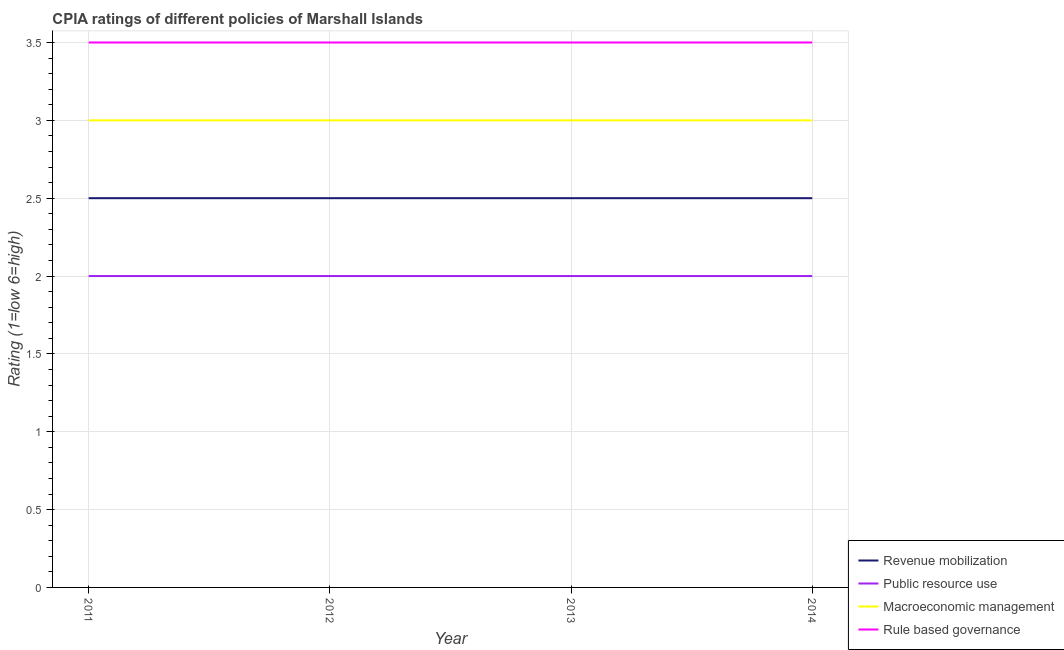How many different coloured lines are there?
Keep it short and to the point. 4. What is the total cpia rating of public resource use in the graph?
Your answer should be compact. 8. What is the difference between the cpia rating of revenue mobilization in 2011 and that in 2012?
Make the answer very short. 0. What is the average cpia rating of public resource use per year?
Your response must be concise. 2. Is it the case that in every year, the sum of the cpia rating of rule based governance and cpia rating of revenue mobilization is greater than the sum of cpia rating of public resource use and cpia rating of macroeconomic management?
Provide a short and direct response. No. Is it the case that in every year, the sum of the cpia rating of revenue mobilization and cpia rating of public resource use is greater than the cpia rating of macroeconomic management?
Ensure brevity in your answer.  Yes. Does the cpia rating of revenue mobilization monotonically increase over the years?
Make the answer very short. No. Is the cpia rating of macroeconomic management strictly greater than the cpia rating of rule based governance over the years?
Keep it short and to the point. No. How many lines are there?
Provide a succinct answer. 4. How many years are there in the graph?
Offer a very short reply. 4. What is the difference between two consecutive major ticks on the Y-axis?
Your answer should be very brief. 0.5. Are the values on the major ticks of Y-axis written in scientific E-notation?
Your answer should be very brief. No. Where does the legend appear in the graph?
Make the answer very short. Bottom right. What is the title of the graph?
Ensure brevity in your answer.  CPIA ratings of different policies of Marshall Islands. Does "Rule based governance" appear as one of the legend labels in the graph?
Offer a very short reply. Yes. What is the Rating (1=low 6=high) of Revenue mobilization in 2011?
Offer a very short reply. 2.5. What is the Rating (1=low 6=high) of Public resource use in 2011?
Offer a very short reply. 2. What is the Rating (1=low 6=high) of Macroeconomic management in 2011?
Provide a succinct answer. 3. What is the Rating (1=low 6=high) of Revenue mobilization in 2013?
Give a very brief answer. 2.5. What is the Rating (1=low 6=high) in Macroeconomic management in 2013?
Keep it short and to the point. 3. What is the Rating (1=low 6=high) in Rule based governance in 2013?
Your response must be concise. 3.5. What is the Rating (1=low 6=high) of Revenue mobilization in 2014?
Provide a succinct answer. 2.5. What is the Rating (1=low 6=high) of Rule based governance in 2014?
Your answer should be very brief. 3.5. Across all years, what is the maximum Rating (1=low 6=high) in Revenue mobilization?
Give a very brief answer. 2.5. Across all years, what is the maximum Rating (1=low 6=high) of Public resource use?
Offer a terse response. 2. Across all years, what is the minimum Rating (1=low 6=high) of Public resource use?
Keep it short and to the point. 2. Across all years, what is the minimum Rating (1=low 6=high) in Macroeconomic management?
Provide a succinct answer. 3. Across all years, what is the minimum Rating (1=low 6=high) in Rule based governance?
Give a very brief answer. 3.5. What is the total Rating (1=low 6=high) of Revenue mobilization in the graph?
Provide a short and direct response. 10. What is the difference between the Rating (1=low 6=high) in Revenue mobilization in 2011 and that in 2012?
Provide a short and direct response. 0. What is the difference between the Rating (1=low 6=high) of Public resource use in 2011 and that in 2012?
Give a very brief answer. 0. What is the difference between the Rating (1=low 6=high) in Rule based governance in 2011 and that in 2012?
Offer a terse response. 0. What is the difference between the Rating (1=low 6=high) of Rule based governance in 2011 and that in 2013?
Offer a terse response. 0. What is the difference between the Rating (1=low 6=high) in Macroeconomic management in 2011 and that in 2014?
Ensure brevity in your answer.  0. What is the difference between the Rating (1=low 6=high) in Public resource use in 2012 and that in 2013?
Offer a very short reply. 0. What is the difference between the Rating (1=low 6=high) in Macroeconomic management in 2012 and that in 2013?
Provide a succinct answer. 0. What is the difference between the Rating (1=low 6=high) in Revenue mobilization in 2012 and that in 2014?
Your answer should be compact. 0. What is the difference between the Rating (1=low 6=high) in Public resource use in 2012 and that in 2014?
Offer a very short reply. 0. What is the difference between the Rating (1=low 6=high) of Macroeconomic management in 2012 and that in 2014?
Your response must be concise. 0. What is the difference between the Rating (1=low 6=high) in Public resource use in 2013 and that in 2014?
Your answer should be very brief. 0. What is the difference between the Rating (1=low 6=high) in Rule based governance in 2013 and that in 2014?
Provide a succinct answer. 0. What is the difference between the Rating (1=low 6=high) in Revenue mobilization in 2011 and the Rating (1=low 6=high) in Public resource use in 2012?
Offer a terse response. 0.5. What is the difference between the Rating (1=low 6=high) of Revenue mobilization in 2011 and the Rating (1=low 6=high) of Macroeconomic management in 2012?
Your response must be concise. -0.5. What is the difference between the Rating (1=low 6=high) of Revenue mobilization in 2011 and the Rating (1=low 6=high) of Rule based governance in 2012?
Provide a succinct answer. -1. What is the difference between the Rating (1=low 6=high) of Public resource use in 2011 and the Rating (1=low 6=high) of Rule based governance in 2012?
Give a very brief answer. -1.5. What is the difference between the Rating (1=low 6=high) of Revenue mobilization in 2011 and the Rating (1=low 6=high) of Rule based governance in 2013?
Keep it short and to the point. -1. What is the difference between the Rating (1=low 6=high) in Public resource use in 2011 and the Rating (1=low 6=high) in Macroeconomic management in 2013?
Your response must be concise. -1. What is the difference between the Rating (1=low 6=high) of Revenue mobilization in 2011 and the Rating (1=low 6=high) of Public resource use in 2014?
Offer a very short reply. 0.5. What is the difference between the Rating (1=low 6=high) of Public resource use in 2011 and the Rating (1=low 6=high) of Macroeconomic management in 2014?
Offer a terse response. -1. What is the difference between the Rating (1=low 6=high) of Public resource use in 2011 and the Rating (1=low 6=high) of Rule based governance in 2014?
Your answer should be very brief. -1.5. What is the difference between the Rating (1=low 6=high) of Macroeconomic management in 2011 and the Rating (1=low 6=high) of Rule based governance in 2014?
Provide a short and direct response. -0.5. What is the difference between the Rating (1=low 6=high) of Revenue mobilization in 2012 and the Rating (1=low 6=high) of Rule based governance in 2013?
Your answer should be compact. -1. What is the difference between the Rating (1=low 6=high) in Public resource use in 2012 and the Rating (1=low 6=high) in Rule based governance in 2013?
Provide a succinct answer. -1.5. What is the difference between the Rating (1=low 6=high) in Revenue mobilization in 2012 and the Rating (1=low 6=high) in Rule based governance in 2014?
Keep it short and to the point. -1. What is the difference between the Rating (1=low 6=high) of Public resource use in 2012 and the Rating (1=low 6=high) of Macroeconomic management in 2014?
Your response must be concise. -1. What is the difference between the Rating (1=low 6=high) in Public resource use in 2012 and the Rating (1=low 6=high) in Rule based governance in 2014?
Provide a succinct answer. -1.5. What is the difference between the Rating (1=low 6=high) in Revenue mobilization in 2013 and the Rating (1=low 6=high) in Public resource use in 2014?
Make the answer very short. 0.5. What is the difference between the Rating (1=low 6=high) in Revenue mobilization in 2013 and the Rating (1=low 6=high) in Macroeconomic management in 2014?
Your answer should be compact. -0.5. What is the difference between the Rating (1=low 6=high) in Macroeconomic management in 2013 and the Rating (1=low 6=high) in Rule based governance in 2014?
Your response must be concise. -0.5. What is the average Rating (1=low 6=high) in Revenue mobilization per year?
Ensure brevity in your answer.  2.5. What is the average Rating (1=low 6=high) of Public resource use per year?
Give a very brief answer. 2. What is the average Rating (1=low 6=high) of Macroeconomic management per year?
Offer a terse response. 3. What is the average Rating (1=low 6=high) in Rule based governance per year?
Provide a short and direct response. 3.5. In the year 2011, what is the difference between the Rating (1=low 6=high) of Revenue mobilization and Rating (1=low 6=high) of Public resource use?
Your answer should be compact. 0.5. In the year 2011, what is the difference between the Rating (1=low 6=high) in Public resource use and Rating (1=low 6=high) in Rule based governance?
Your answer should be compact. -1.5. In the year 2012, what is the difference between the Rating (1=low 6=high) of Revenue mobilization and Rating (1=low 6=high) of Public resource use?
Your answer should be compact. 0.5. In the year 2012, what is the difference between the Rating (1=low 6=high) in Public resource use and Rating (1=low 6=high) in Rule based governance?
Offer a terse response. -1.5. In the year 2012, what is the difference between the Rating (1=low 6=high) of Macroeconomic management and Rating (1=low 6=high) of Rule based governance?
Offer a terse response. -0.5. In the year 2013, what is the difference between the Rating (1=low 6=high) in Revenue mobilization and Rating (1=low 6=high) in Macroeconomic management?
Your response must be concise. -0.5. In the year 2014, what is the difference between the Rating (1=low 6=high) in Revenue mobilization and Rating (1=low 6=high) in Rule based governance?
Make the answer very short. -1. In the year 2014, what is the difference between the Rating (1=low 6=high) of Public resource use and Rating (1=low 6=high) of Macroeconomic management?
Your response must be concise. -1. In the year 2014, what is the difference between the Rating (1=low 6=high) of Macroeconomic management and Rating (1=low 6=high) of Rule based governance?
Give a very brief answer. -0.5. What is the ratio of the Rating (1=low 6=high) in Public resource use in 2011 to that in 2012?
Your response must be concise. 1. What is the ratio of the Rating (1=low 6=high) of Public resource use in 2011 to that in 2013?
Your response must be concise. 1. What is the ratio of the Rating (1=low 6=high) of Revenue mobilization in 2012 to that in 2013?
Give a very brief answer. 1. What is the ratio of the Rating (1=low 6=high) in Macroeconomic management in 2012 to that in 2013?
Keep it short and to the point. 1. What is the ratio of the Rating (1=low 6=high) in Revenue mobilization in 2012 to that in 2014?
Your answer should be compact. 1. What is the ratio of the Rating (1=low 6=high) of Revenue mobilization in 2013 to that in 2014?
Provide a succinct answer. 1. What is the ratio of the Rating (1=low 6=high) of Rule based governance in 2013 to that in 2014?
Provide a short and direct response. 1. What is the difference between the highest and the second highest Rating (1=low 6=high) of Macroeconomic management?
Make the answer very short. 0. What is the difference between the highest and the lowest Rating (1=low 6=high) in Rule based governance?
Ensure brevity in your answer.  0. 